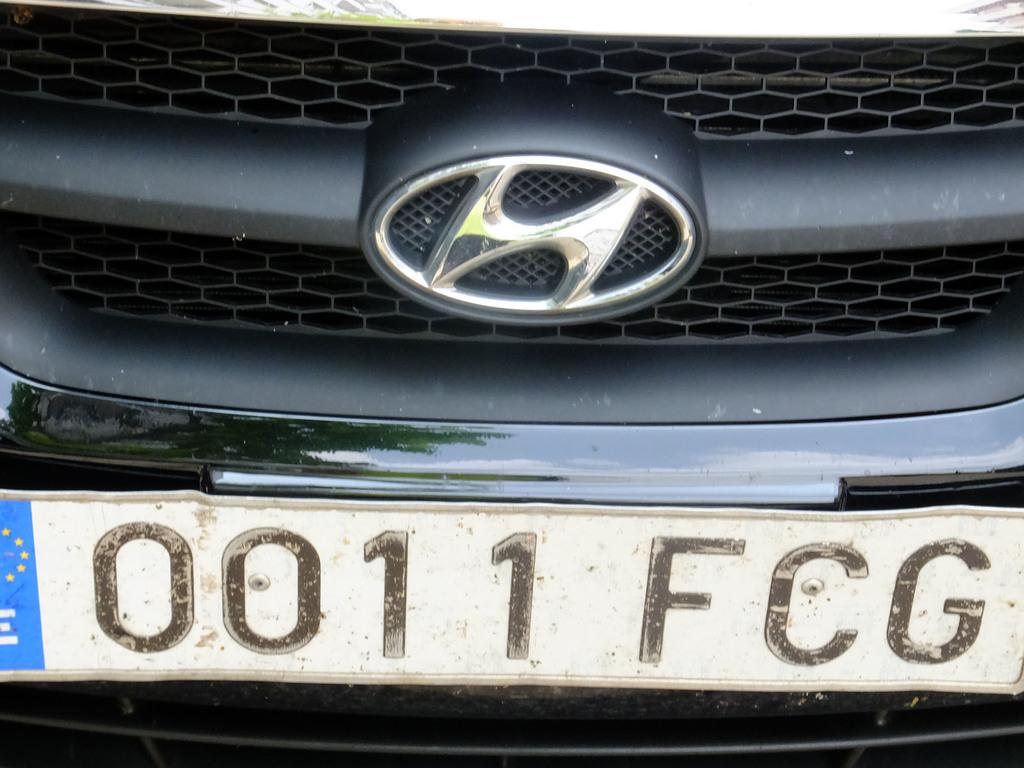What is the license plate number?
Offer a very short reply. 0011 fcg. What letter represents the car brand?
Your response must be concise. H. 